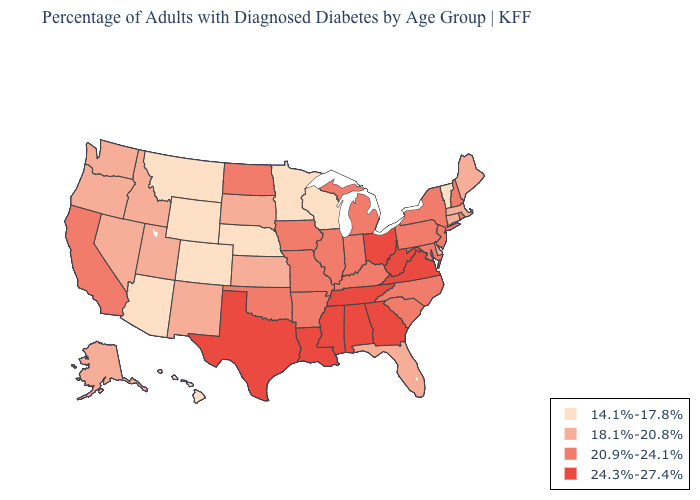Among the states that border Arkansas , which have the highest value?
Short answer required. Louisiana, Mississippi, Tennessee, Texas. Name the states that have a value in the range 14.1%-17.8%?
Concise answer only. Arizona, Colorado, Hawaii, Minnesota, Montana, Nebraska, Vermont, Wisconsin, Wyoming. Which states have the lowest value in the South?
Quick response, please. Delaware, Florida. Name the states that have a value in the range 20.9%-24.1%?
Concise answer only. Arkansas, California, Illinois, Indiana, Iowa, Kentucky, Maryland, Michigan, Missouri, New Hampshire, New Jersey, New York, North Carolina, North Dakota, Oklahoma, Pennsylvania, Rhode Island, South Carolina. What is the lowest value in states that border Idaho?
Give a very brief answer. 14.1%-17.8%. What is the highest value in the USA?
Be succinct. 24.3%-27.4%. Does Georgia have the same value as Pennsylvania?
Be succinct. No. What is the value of Arkansas?
Give a very brief answer. 20.9%-24.1%. What is the lowest value in states that border Utah?
Give a very brief answer. 14.1%-17.8%. Name the states that have a value in the range 24.3%-27.4%?
Give a very brief answer. Alabama, Georgia, Louisiana, Mississippi, Ohio, Tennessee, Texas, Virginia, West Virginia. What is the value of South Dakota?
Write a very short answer. 18.1%-20.8%. What is the value of Alabama?
Keep it brief. 24.3%-27.4%. What is the value of Indiana?
Give a very brief answer. 20.9%-24.1%. Which states hav the highest value in the West?
Be succinct. California. What is the value of Vermont?
Write a very short answer. 14.1%-17.8%. 